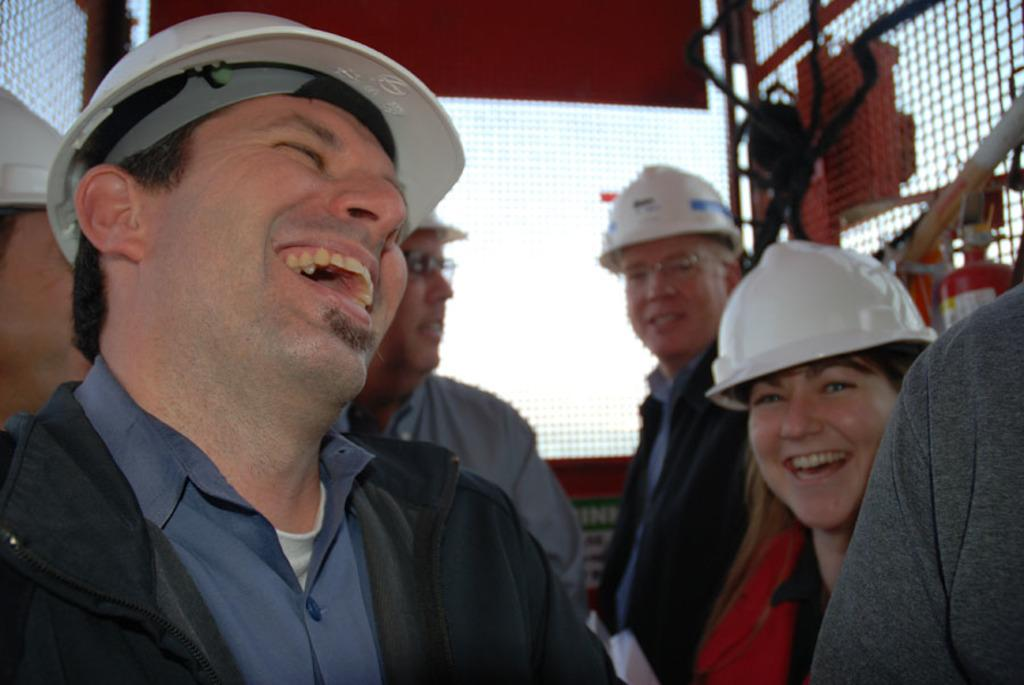How many people are in the group shown in the image? There is a group of people in the image, but the exact number is not specified. What is the general expression of the people in the group? Most of the people in the group are smiling. What can be seen surrounding the group of people? There are grills made up of meshes around the group of people. What type of religious ceremony is taking place in the image? There is no indication of a religious ceremony in the image; it simply shows a group of people with grills made up of meshes around them. Can you see any celery being used in the image? There is no celery present in the image. 